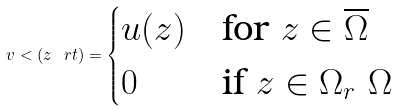<formula> <loc_0><loc_0><loc_500><loc_500>v < ( z \ r t ) = \begin{cases} u ( z ) & \text {for } z \in \overline { \Omega } \\ 0 & \text {if } z \in \Omega _ { r } \ \Omega \end{cases}</formula> 